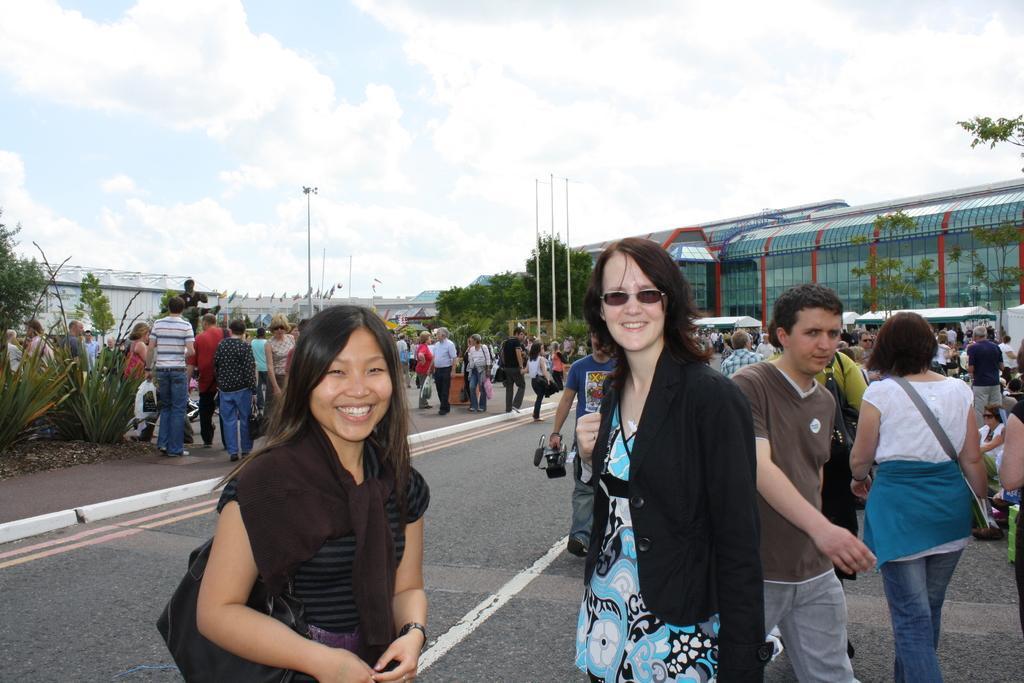Could you give a brief overview of what you see in this image? In this picture there are two girls in the center of the image and there are other people on the right and left side of the image, there are trees and buildings in the background area of the image. 